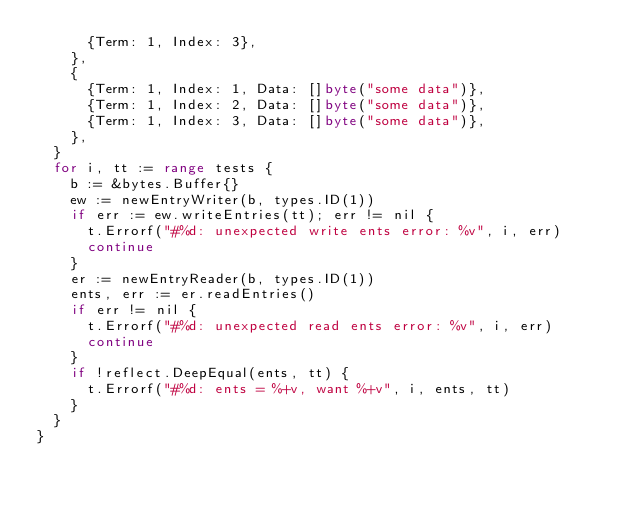Convert code to text. <code><loc_0><loc_0><loc_500><loc_500><_Go_>			{Term: 1, Index: 3},
		},
		{
			{Term: 1, Index: 1, Data: []byte("some data")},
			{Term: 1, Index: 2, Data: []byte("some data")},
			{Term: 1, Index: 3, Data: []byte("some data")},
		},
	}
	for i, tt := range tests {
		b := &bytes.Buffer{}
		ew := newEntryWriter(b, types.ID(1))
		if err := ew.writeEntries(tt); err != nil {
			t.Errorf("#%d: unexpected write ents error: %v", i, err)
			continue
		}
		er := newEntryReader(b, types.ID(1))
		ents, err := er.readEntries()
		if err != nil {
			t.Errorf("#%d: unexpected read ents error: %v", i, err)
			continue
		}
		if !reflect.DeepEqual(ents, tt) {
			t.Errorf("#%d: ents = %+v, want %+v", i, ents, tt)
		}
	}
}
</code> 